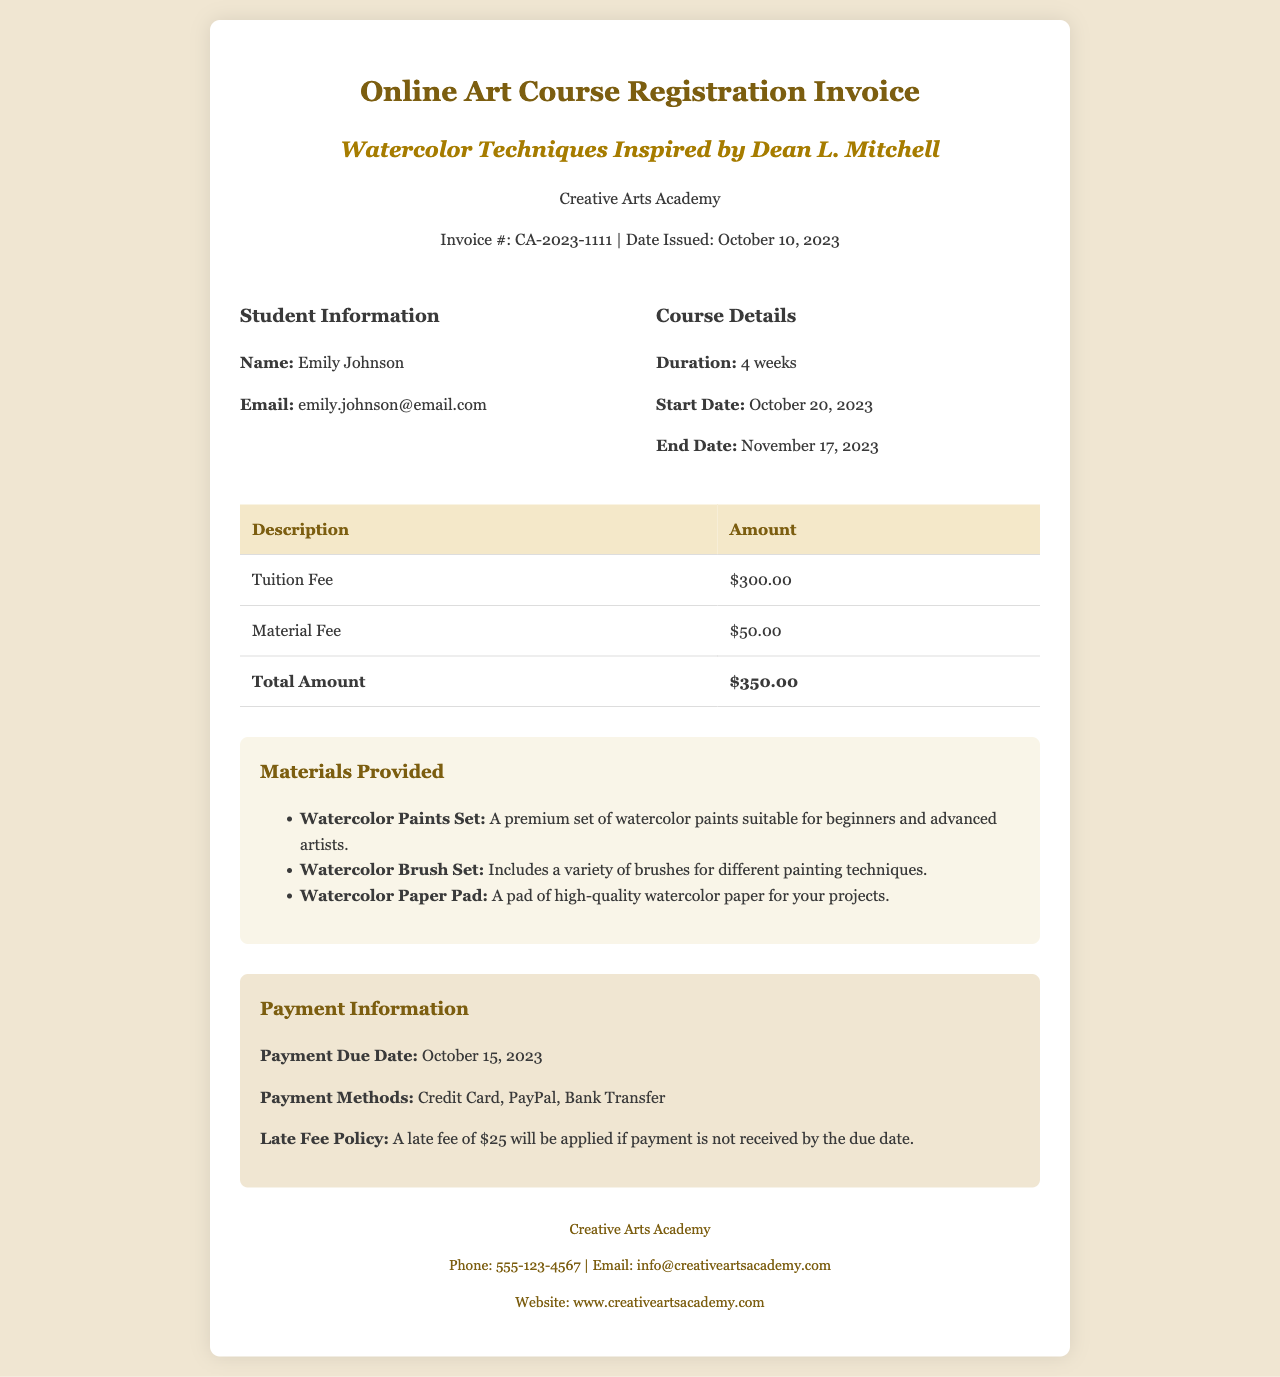What is the invoice number? The invoice number is specified in the document, which is CA-2023-1111.
Answer: CA-2023-1111 Who is the student? The student's name is mentioned in the document as Emily Johnson.
Answer: Emily Johnson What is the total amount? The total amount is provided at the bottom of the fee table, which is $350.00.
Answer: $350.00 When is the payment due? The payment due date is clearly stated in the payment information section, which is October 15, 2023.
Answer: October 15, 2023 What materials are provided? The materials provided section lists three specific items, including a Watercolor Paints Set.
Answer: Watercolor Paints Set How long is the course duration? The course duration is mentioned in the course details section as 4 weeks.
Answer: 4 weeks What is the late fee? The late fee policy specified in the document indicates that a late fee of $25 will be applied.
Answer: $25 What is the start date of the course? The start date of the course is specified in the course details as October 20, 2023.
Answer: October 20, 2023 What payment methods are accepted? The document mentions the accepted payment methods, which include Credit Card, PayPal, and Bank Transfer.
Answer: Credit Card, PayPal, Bank Transfer 